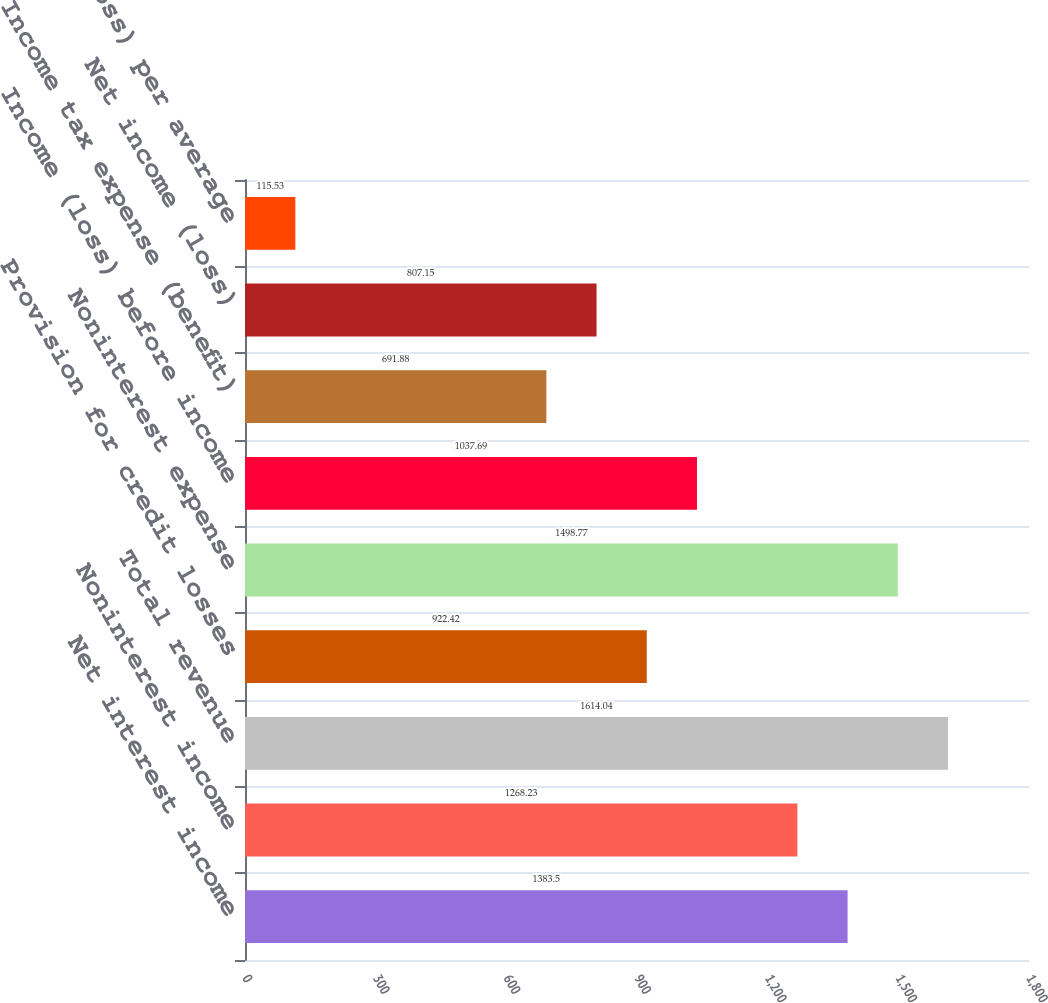<chart> <loc_0><loc_0><loc_500><loc_500><bar_chart><fcel>Net interest income<fcel>Noninterest income<fcel>Total revenue<fcel>Provision for credit losses<fcel>Noninterest expense<fcel>Income (loss) before income<fcel>Income tax expense (benefit)<fcel>Net income (loss)<fcel>Net income (loss) per average<nl><fcel>1383.5<fcel>1268.23<fcel>1614.04<fcel>922.42<fcel>1498.77<fcel>1037.69<fcel>691.88<fcel>807.15<fcel>115.53<nl></chart> 